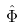<formula> <loc_0><loc_0><loc_500><loc_500>\hat { \Phi }</formula> 